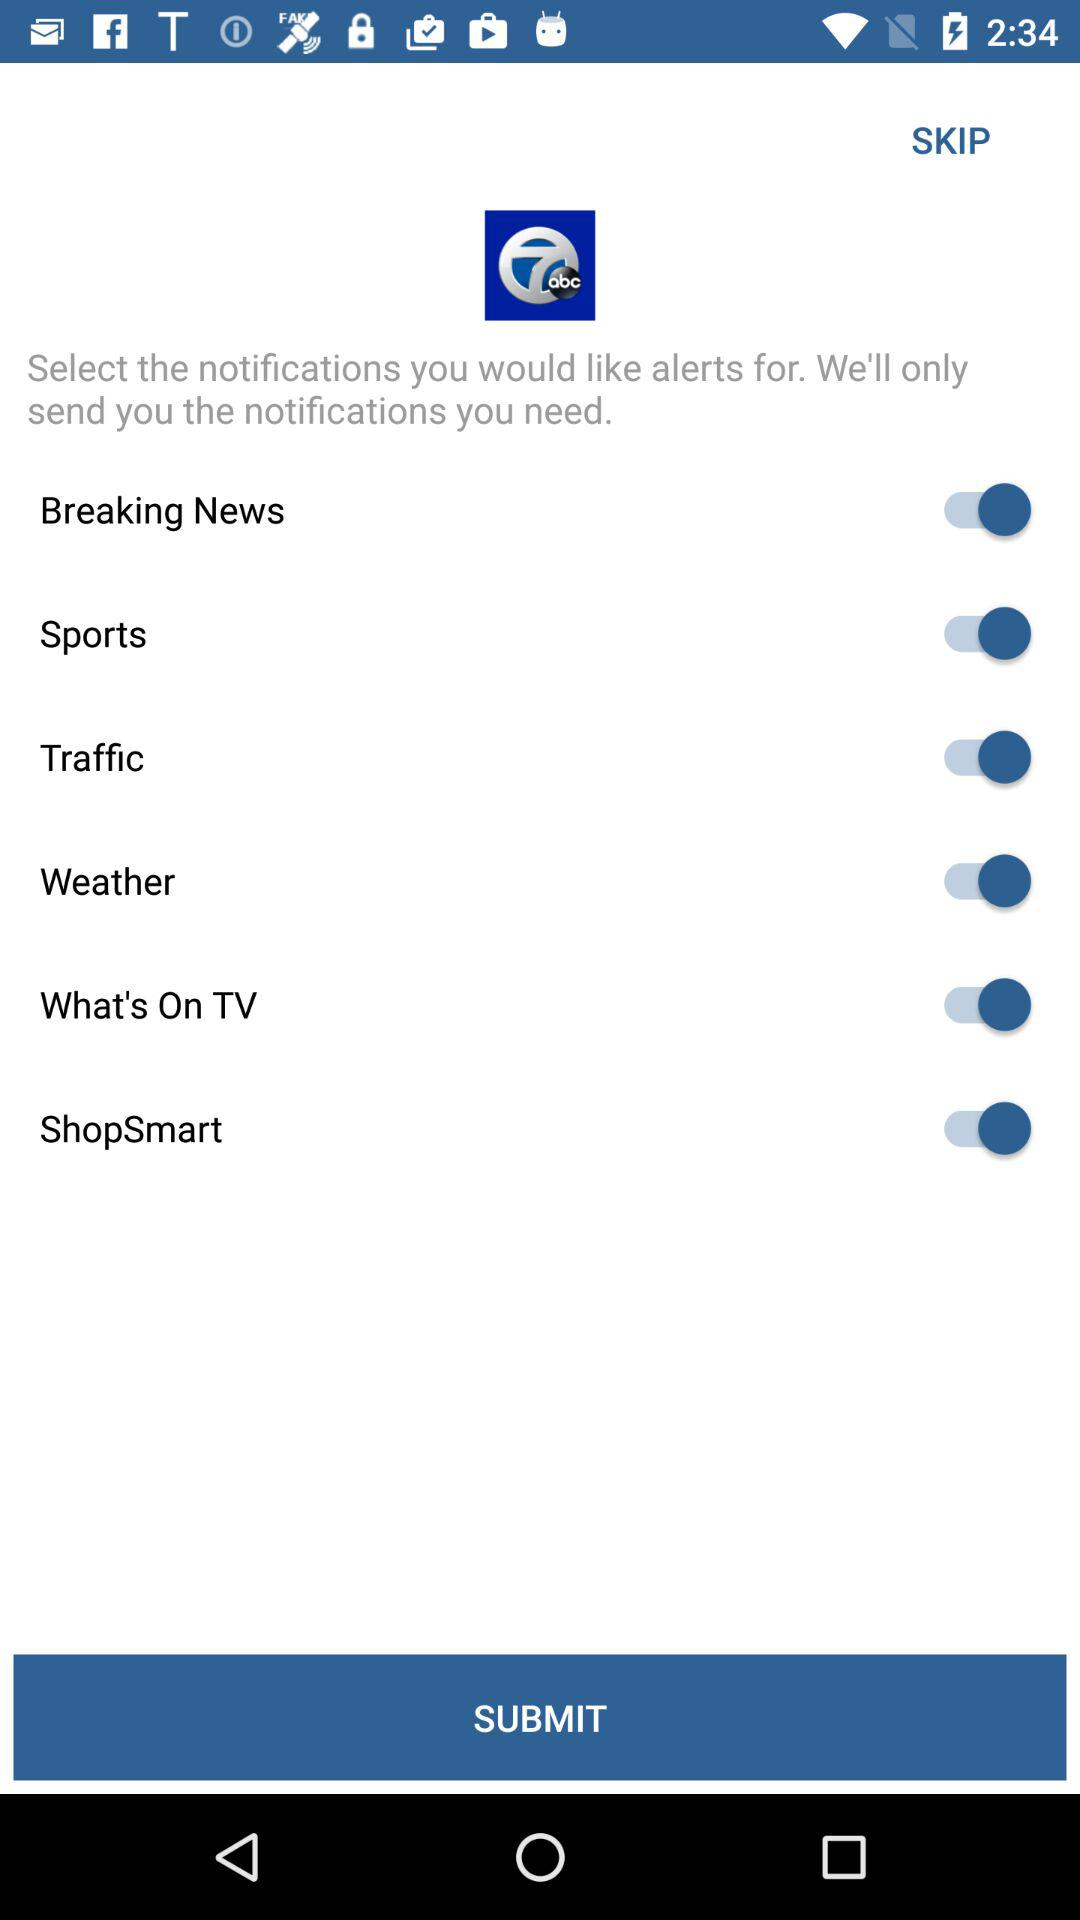What is the status of breaking news? The status of breaking news is on. 